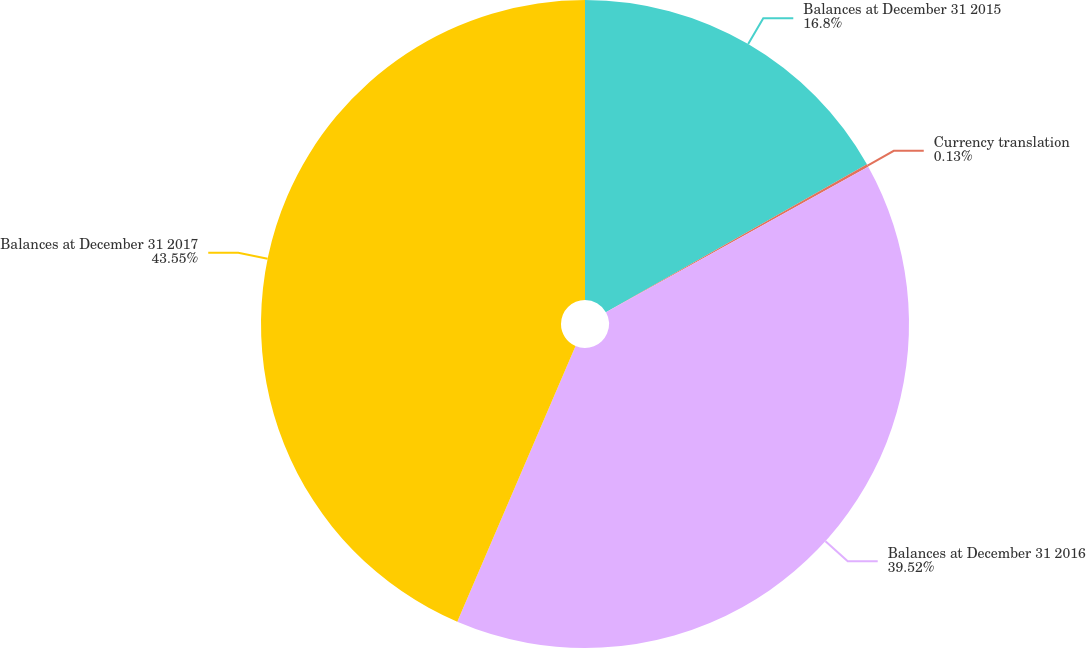Convert chart to OTSL. <chart><loc_0><loc_0><loc_500><loc_500><pie_chart><fcel>Balances at December 31 2015<fcel>Currency translation<fcel>Balances at December 31 2016<fcel>Balances at December 31 2017<nl><fcel>16.8%<fcel>0.13%<fcel>39.52%<fcel>43.55%<nl></chart> 